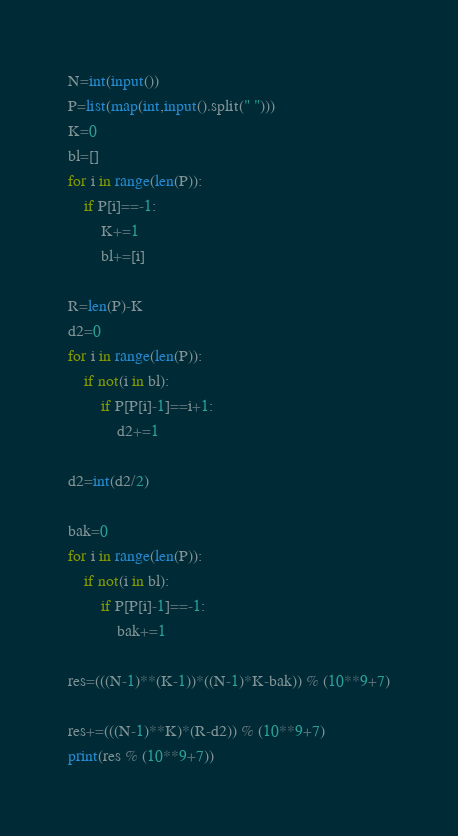<code> <loc_0><loc_0><loc_500><loc_500><_Python_>N=int(input())
P=list(map(int,input().split(" ")))
K=0
bl=[]
for i in range(len(P)):
    if P[i]==-1:
        K+=1
        bl+=[i]

R=len(P)-K
d2=0
for i in range(len(P)):
    if not(i in bl):
        if P[P[i]-1]==i+1:
            d2+=1

d2=int(d2/2)

bak=0
for i in range(len(P)):
    if not(i in bl):
        if P[P[i]-1]==-1:
            bak+=1

res=(((N-1)**(K-1))*((N-1)*K-bak)) % (10**9+7)

res+=(((N-1)**K)*(R-d2)) % (10**9+7)
print(res % (10**9+7))</code> 